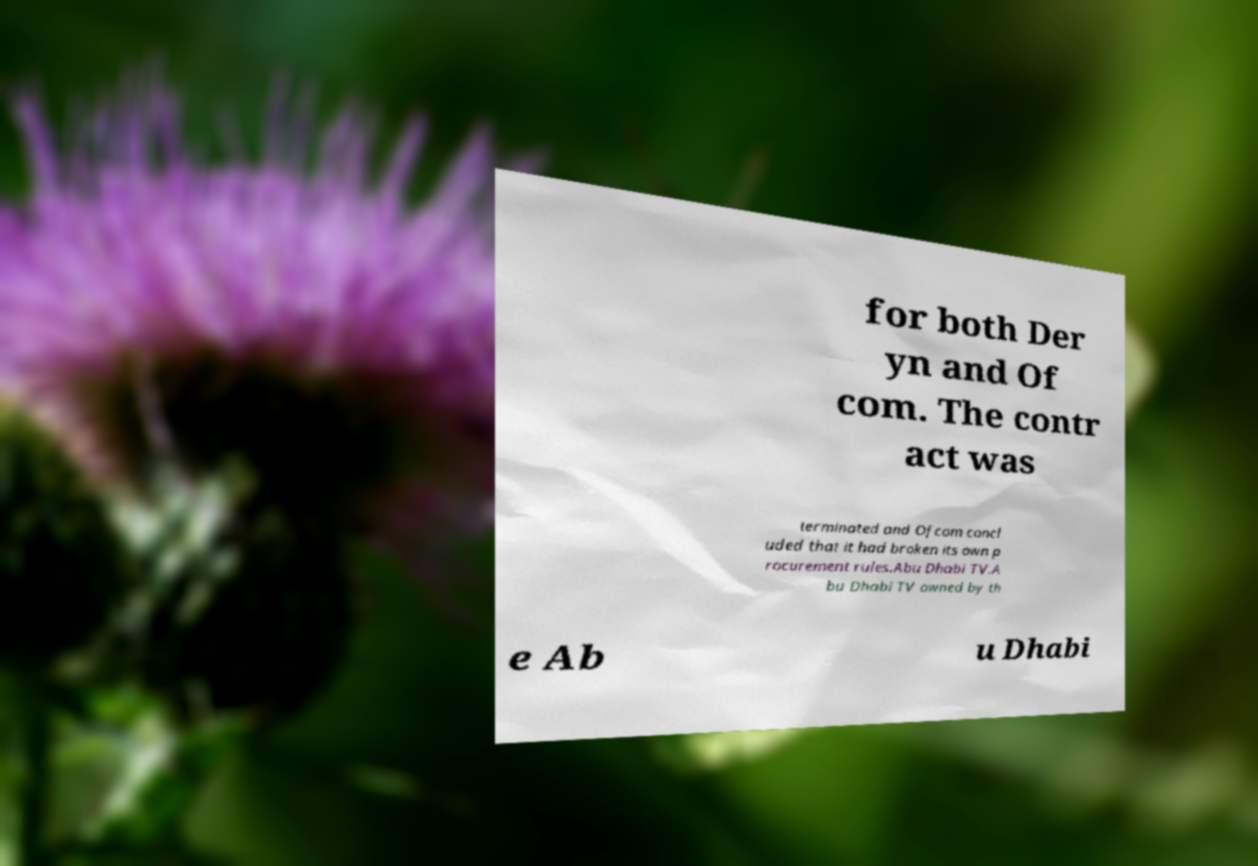Can you read and provide the text displayed in the image?This photo seems to have some interesting text. Can you extract and type it out for me? for both Der yn and Of com. The contr act was terminated and Ofcom concl uded that it had broken its own p rocurement rules.Abu Dhabi TV.A bu Dhabi TV owned by th e Ab u Dhabi 